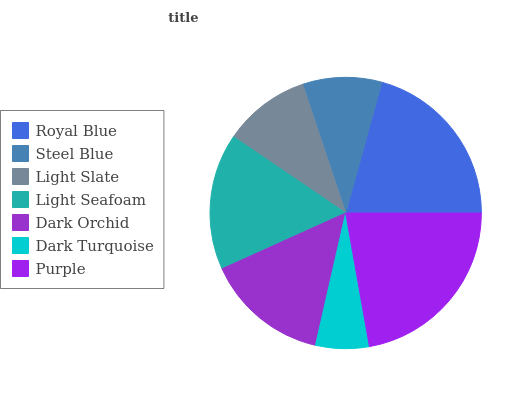Is Dark Turquoise the minimum?
Answer yes or no. Yes. Is Purple the maximum?
Answer yes or no. Yes. Is Steel Blue the minimum?
Answer yes or no. No. Is Steel Blue the maximum?
Answer yes or no. No. Is Royal Blue greater than Steel Blue?
Answer yes or no. Yes. Is Steel Blue less than Royal Blue?
Answer yes or no. Yes. Is Steel Blue greater than Royal Blue?
Answer yes or no. No. Is Royal Blue less than Steel Blue?
Answer yes or no. No. Is Dark Orchid the high median?
Answer yes or no. Yes. Is Dark Orchid the low median?
Answer yes or no. Yes. Is Royal Blue the high median?
Answer yes or no. No. Is Dark Turquoise the low median?
Answer yes or no. No. 